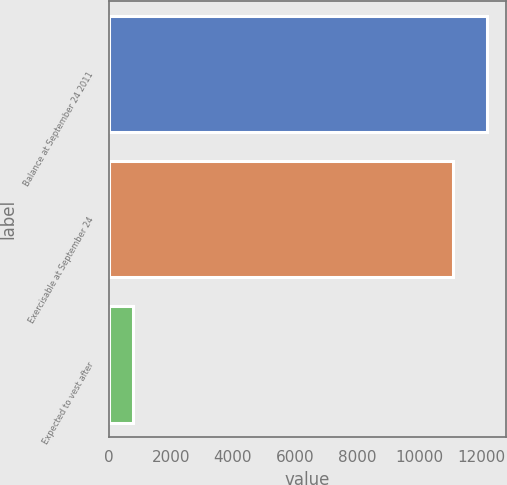<chart> <loc_0><loc_0><loc_500><loc_500><bar_chart><fcel>Balance at September 24 2011<fcel>Exercisable at September 24<fcel>Expected to vest after<nl><fcel>12197.9<fcel>11089<fcel>777<nl></chart> 